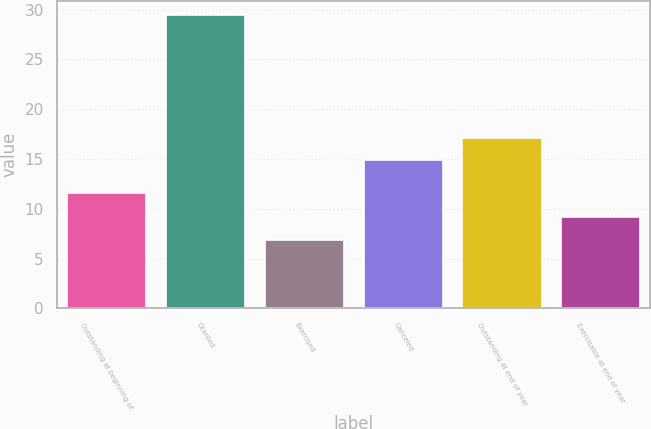Convert chart to OTSL. <chart><loc_0><loc_0><loc_500><loc_500><bar_chart><fcel>Outstanding at beginning of<fcel>Granted<fcel>Exercised<fcel>Canceled<fcel>Outstanding at end of year<fcel>Exercisable at end of year<nl><fcel>11.55<fcel>29.44<fcel>6.89<fcel>14.9<fcel>17.16<fcel>9.14<nl></chart> 